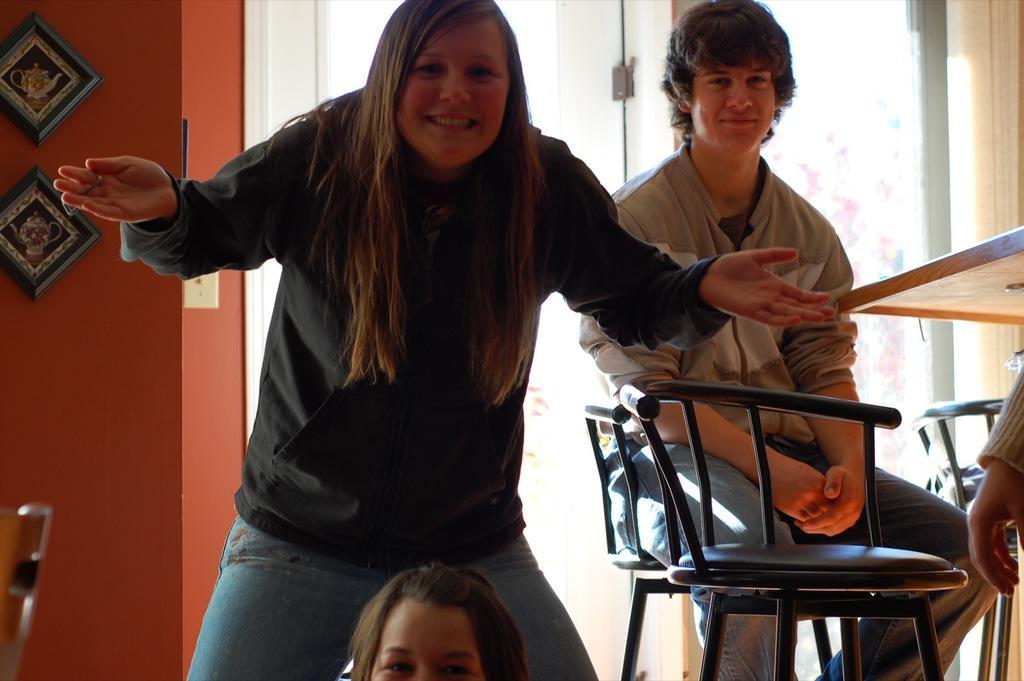Please provide a concise description of this image. Here we can see two women and a guy sitting on chair behind the woman, this woman is standing and she is laughing we can quite clearly say that, the guy is also laughing. Here we can see a window, here we can see a wall, there are couple of chairs here. This woman is spreading her hands. 